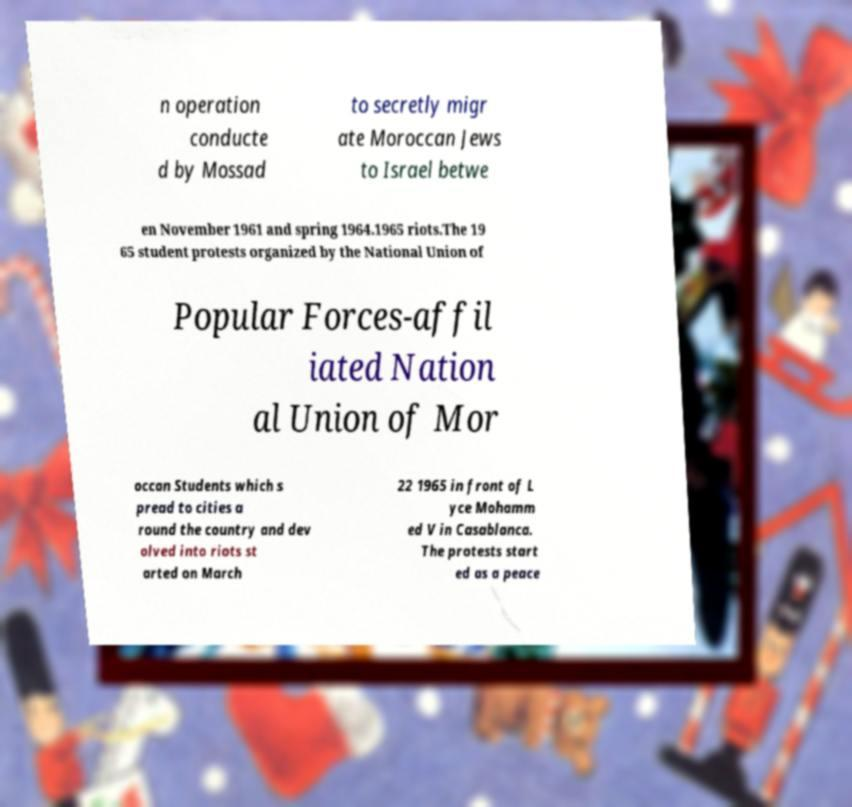Please identify and transcribe the text found in this image. n operation conducte d by Mossad to secretly migr ate Moroccan Jews to Israel betwe en November 1961 and spring 1964.1965 riots.The 19 65 student protests organized by the National Union of Popular Forces-affil iated Nation al Union of Mor occan Students which s pread to cities a round the country and dev olved into riots st arted on March 22 1965 in front of L yce Mohamm ed V in Casablanca. The protests start ed as a peace 